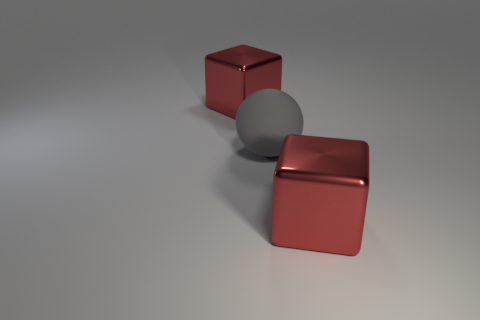Add 3 large yellow objects. How many objects exist? 6 Subtract all cubes. How many objects are left? 1 Subtract all big brown matte objects. Subtract all red cubes. How many objects are left? 1 Add 3 large rubber spheres. How many large rubber spheres are left? 4 Add 3 tiny red metal balls. How many tiny red metal balls exist? 3 Subtract 0 green cylinders. How many objects are left? 3 